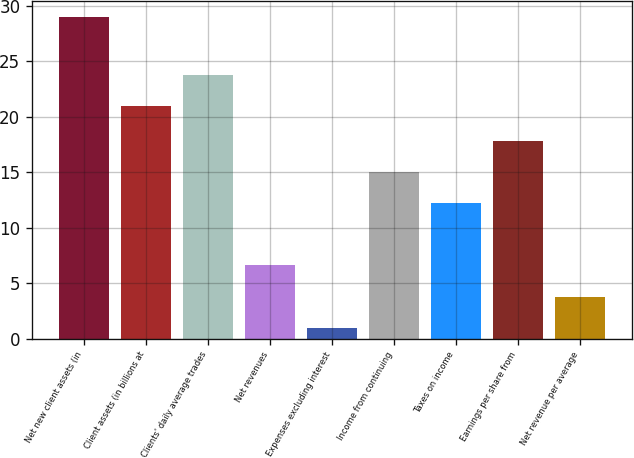Convert chart. <chart><loc_0><loc_0><loc_500><loc_500><bar_chart><fcel>Net new client assets (in<fcel>Client assets (in billions at<fcel>Clients' daily average trades<fcel>Net revenues<fcel>Expenses excluding interest<fcel>Income from continuing<fcel>Taxes on income<fcel>Earnings per share from<fcel>Net revenue per average<nl><fcel>29<fcel>21<fcel>23.8<fcel>6.6<fcel>1<fcel>15<fcel>12.2<fcel>17.8<fcel>3.8<nl></chart> 